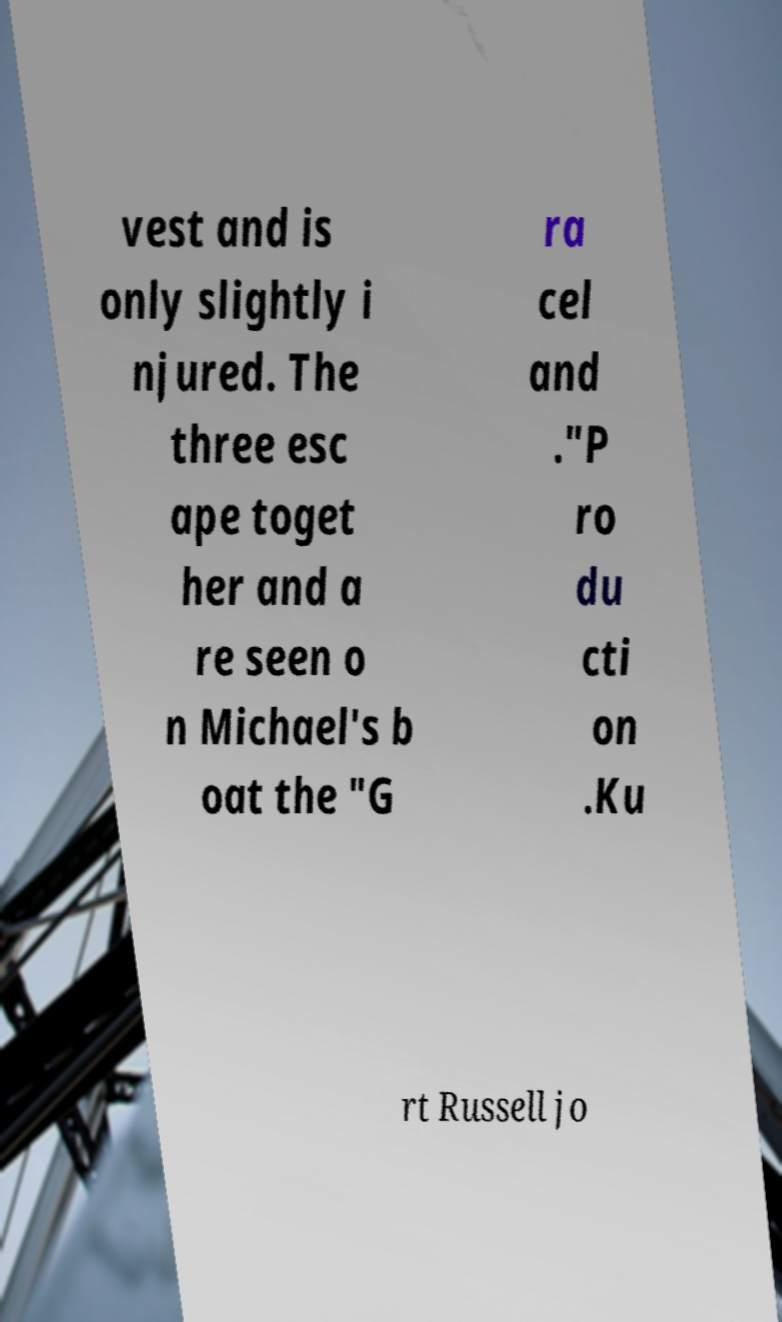Please identify and transcribe the text found in this image. vest and is only slightly i njured. The three esc ape toget her and a re seen o n Michael's b oat the "G ra cel and ."P ro du cti on .Ku rt Russell jo 